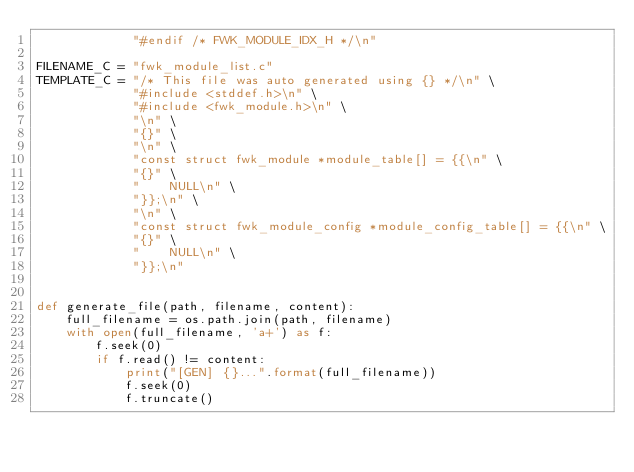<code> <loc_0><loc_0><loc_500><loc_500><_Python_>             "#endif /* FWK_MODULE_IDX_H */\n"

FILENAME_C = "fwk_module_list.c"
TEMPLATE_C = "/* This file was auto generated using {} */\n" \
             "#include <stddef.h>\n" \
             "#include <fwk_module.h>\n" \
             "\n" \
             "{}" \
             "\n" \
             "const struct fwk_module *module_table[] = {{\n" \
             "{}" \
             "    NULL\n" \
             "}};\n" \
             "\n" \
             "const struct fwk_module_config *module_config_table[] = {{\n" \
             "{}" \
             "    NULL\n" \
             "}};\n"


def generate_file(path, filename, content):
    full_filename = os.path.join(path, filename)
    with open(full_filename, 'a+') as f:
        f.seek(0)
        if f.read() != content:
            print("[GEN] {}...".format(full_filename))
            f.seek(0)
            f.truncate()</code> 